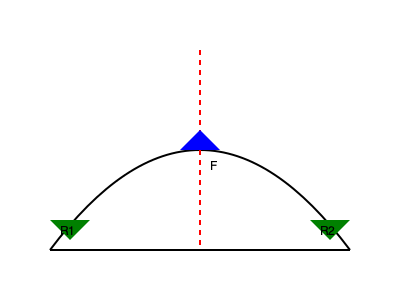In the Gothic arch depicted above, a vertical force $F$ is applied at the keystone. Given that the arch has a span of 6 meters and a rise of 4 meters, calculate the magnitude of the horizontal thrust $H$ at the base of the arch if $F = 10$ kN. Assume the arch is symmetrical and in static equilibrium. To solve this problem, we'll follow these steps:

1) First, we need to understand that in a symmetrical arch, the horizontal thrusts at both bases are equal in magnitude and opposite in direction.

2) The key to solving this problem is to use the principle of moments about one of the supports. Let's choose the left support.

3) The span is 6 m and the rise is 4 m. We can treat the arch as a triangle for this calculation.

4) The moment arm for the vertical force $F$ is half the span, which is 3 m.

5) The moment arm for the horizontal thrust $H$ is the rise, which is 4 m.

6) For equilibrium, the sum of moments about any point should be zero. So:

   $F \cdot 3 - H \cdot 4 = 0$

7) Substituting the known value of $F = 10$ kN:

   $10 \cdot 3 - H \cdot 4 = 0$
   $30 - 4H = 0$
   $4H = 30$

8) Solving for $H$:

   $H = \frac{30}{4} = 7.5$ kN

Therefore, the magnitude of the horizontal thrust at the base of the arch is 7.5 kN.
Answer: 7.5 kN 